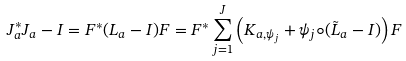Convert formula to latex. <formula><loc_0><loc_0><loc_500><loc_500>J _ { a } ^ { * } J _ { a } - I = F ^ { * } ( L _ { a } - I ) F = F ^ { * } \sum _ { j = 1 } ^ { J } \left ( K _ { a , \psi _ { j } } + \psi _ { j } \circ ( \tilde { L } _ { a } - I ) \right ) F</formula> 